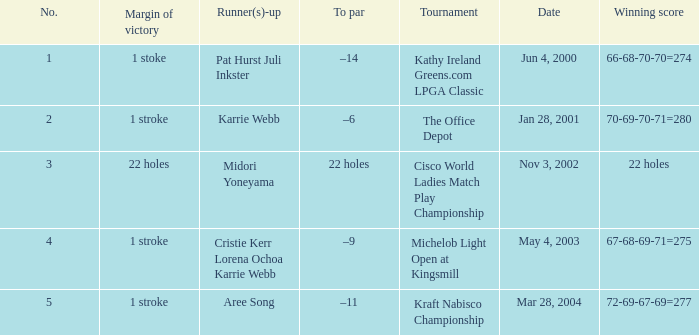What is the to par dated may 4, 2003? –9. 